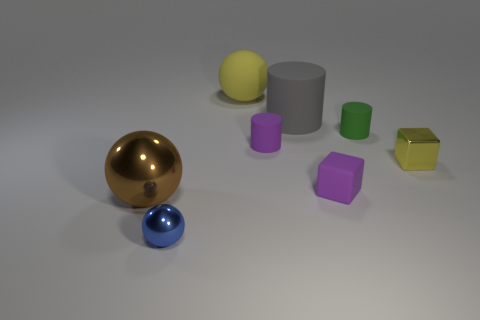Which object appears to be the most reflective? The most reflective object in the image is the golden sphere, as it has a high shine and clearly shows reflections of its surroundings.  What can you infer about the light source in the scene? The light source seems to be coming from above, as indicated by the shadows cast directly below the objects and the highlights visible on the upper surfaces of the objects. 